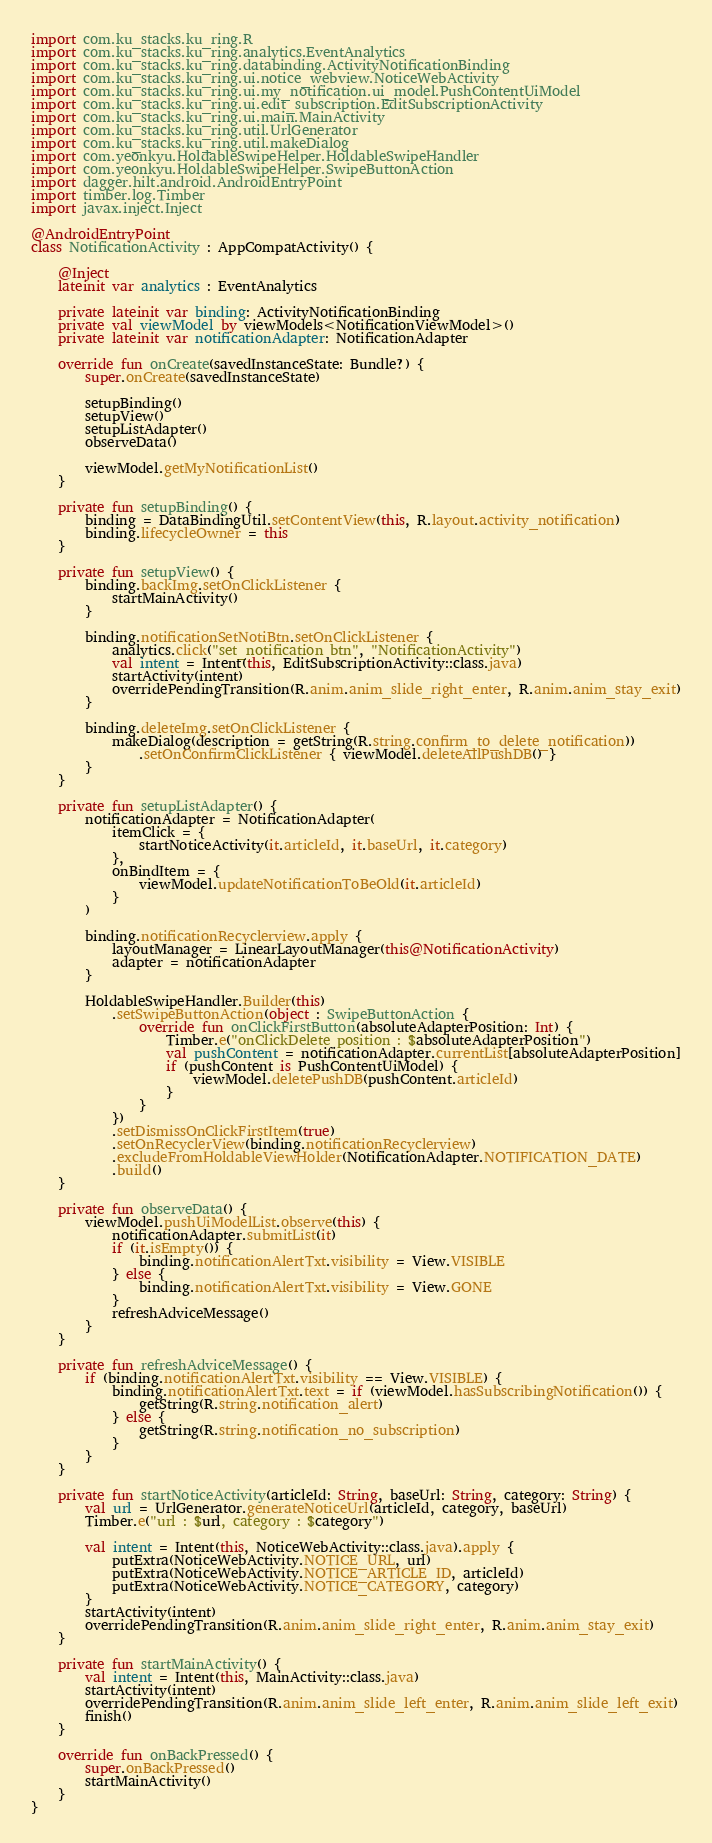Convert code to text. <code><loc_0><loc_0><loc_500><loc_500><_Kotlin_>import com.ku_stacks.ku_ring.R
import com.ku_stacks.ku_ring.analytics.EventAnalytics
import com.ku_stacks.ku_ring.databinding.ActivityNotificationBinding
import com.ku_stacks.ku_ring.ui.notice_webview.NoticeWebActivity
import com.ku_stacks.ku_ring.ui.my_notification.ui_model.PushContentUiModel
import com.ku_stacks.ku_ring.ui.edit_subscription.EditSubscriptionActivity
import com.ku_stacks.ku_ring.ui.main.MainActivity
import com.ku_stacks.ku_ring.util.UrlGenerator
import com.ku_stacks.ku_ring.util.makeDialog
import com.yeonkyu.HoldableSwipeHelper.HoldableSwipeHandler
import com.yeonkyu.HoldableSwipeHelper.SwipeButtonAction
import dagger.hilt.android.AndroidEntryPoint
import timber.log.Timber
import javax.inject.Inject

@AndroidEntryPoint
class NotificationActivity : AppCompatActivity() {

    @Inject
    lateinit var analytics : EventAnalytics

    private lateinit var binding: ActivityNotificationBinding
    private val viewModel by viewModels<NotificationViewModel>()
    private lateinit var notificationAdapter: NotificationAdapter

    override fun onCreate(savedInstanceState: Bundle?) {
        super.onCreate(savedInstanceState)

        setupBinding()
        setupView()
        setupListAdapter()
        observeData()

        viewModel.getMyNotificationList()
    }

    private fun setupBinding() {
        binding = DataBindingUtil.setContentView(this, R.layout.activity_notification)
        binding.lifecycleOwner = this
    }

    private fun setupView() {
        binding.backImg.setOnClickListener {
            startMainActivity()
        }

        binding.notificationSetNotiBtn.setOnClickListener {
            analytics.click("set_notification btn", "NotificationActivity")
            val intent = Intent(this, EditSubscriptionActivity::class.java)
            startActivity(intent)
            overridePendingTransition(R.anim.anim_slide_right_enter, R.anim.anim_stay_exit)
        }

        binding.deleteImg.setOnClickListener {
            makeDialog(description = getString(R.string.confirm_to_delete_notification))
                .setOnConfirmClickListener { viewModel.deleteAllPushDB() }
        }
    }

    private fun setupListAdapter() {
        notificationAdapter = NotificationAdapter(
            itemClick = {
                startNoticeActivity(it.articleId, it.baseUrl, it.category)
            },
            onBindItem = {
                viewModel.updateNotificationToBeOld(it.articleId)
            }
        )

        binding.notificationRecyclerview.apply {
            layoutManager = LinearLayoutManager(this@NotificationActivity)
            adapter = notificationAdapter
        }

        HoldableSwipeHandler.Builder(this)
            .setSwipeButtonAction(object : SwipeButtonAction {
                override fun onClickFirstButton(absoluteAdapterPosition: Int) {
                    Timber.e("onClickDelete position : $absoluteAdapterPosition")
                    val pushContent = notificationAdapter.currentList[absoluteAdapterPosition]
                    if (pushContent is PushContentUiModel) {
                        viewModel.deletePushDB(pushContent.articleId)
                    }
                }
            })
            .setDismissOnClickFirstItem(true)
            .setOnRecyclerView(binding.notificationRecyclerview)
            .excludeFromHoldableViewHolder(NotificationAdapter.NOTIFICATION_DATE)
            .build()
    }

    private fun observeData() {
        viewModel.pushUiModelList.observe(this) {
            notificationAdapter.submitList(it)
            if (it.isEmpty()) {
                binding.notificationAlertTxt.visibility = View.VISIBLE
            } else {
                binding.notificationAlertTxt.visibility = View.GONE
            }
            refreshAdviceMessage()
        }
    }

    private fun refreshAdviceMessage() {
        if (binding.notificationAlertTxt.visibility == View.VISIBLE) {
            binding.notificationAlertTxt.text = if (viewModel.hasSubscribingNotification()) {
                getString(R.string.notification_alert)
            } else {
                getString(R.string.notification_no_subscription)
            }
        }
    }

    private fun startNoticeActivity(articleId: String, baseUrl: String, category: String) {
        val url = UrlGenerator.generateNoticeUrl(articleId, category, baseUrl)
        Timber.e("url : $url, category : $category")

        val intent = Intent(this, NoticeWebActivity::class.java).apply {
            putExtra(NoticeWebActivity.NOTICE_URL, url)
            putExtra(NoticeWebActivity.NOTICE_ARTICLE_ID, articleId)
            putExtra(NoticeWebActivity.NOTICE_CATEGORY, category)
        }
        startActivity(intent)
        overridePendingTransition(R.anim.anim_slide_right_enter, R.anim.anim_stay_exit)
    }

    private fun startMainActivity() {
        val intent = Intent(this, MainActivity::class.java)
        startActivity(intent)
        overridePendingTransition(R.anim.anim_slide_left_enter, R.anim.anim_slide_left_exit)
        finish()
    }

    override fun onBackPressed() {
        super.onBackPressed()
        startMainActivity()
    }
}</code> 